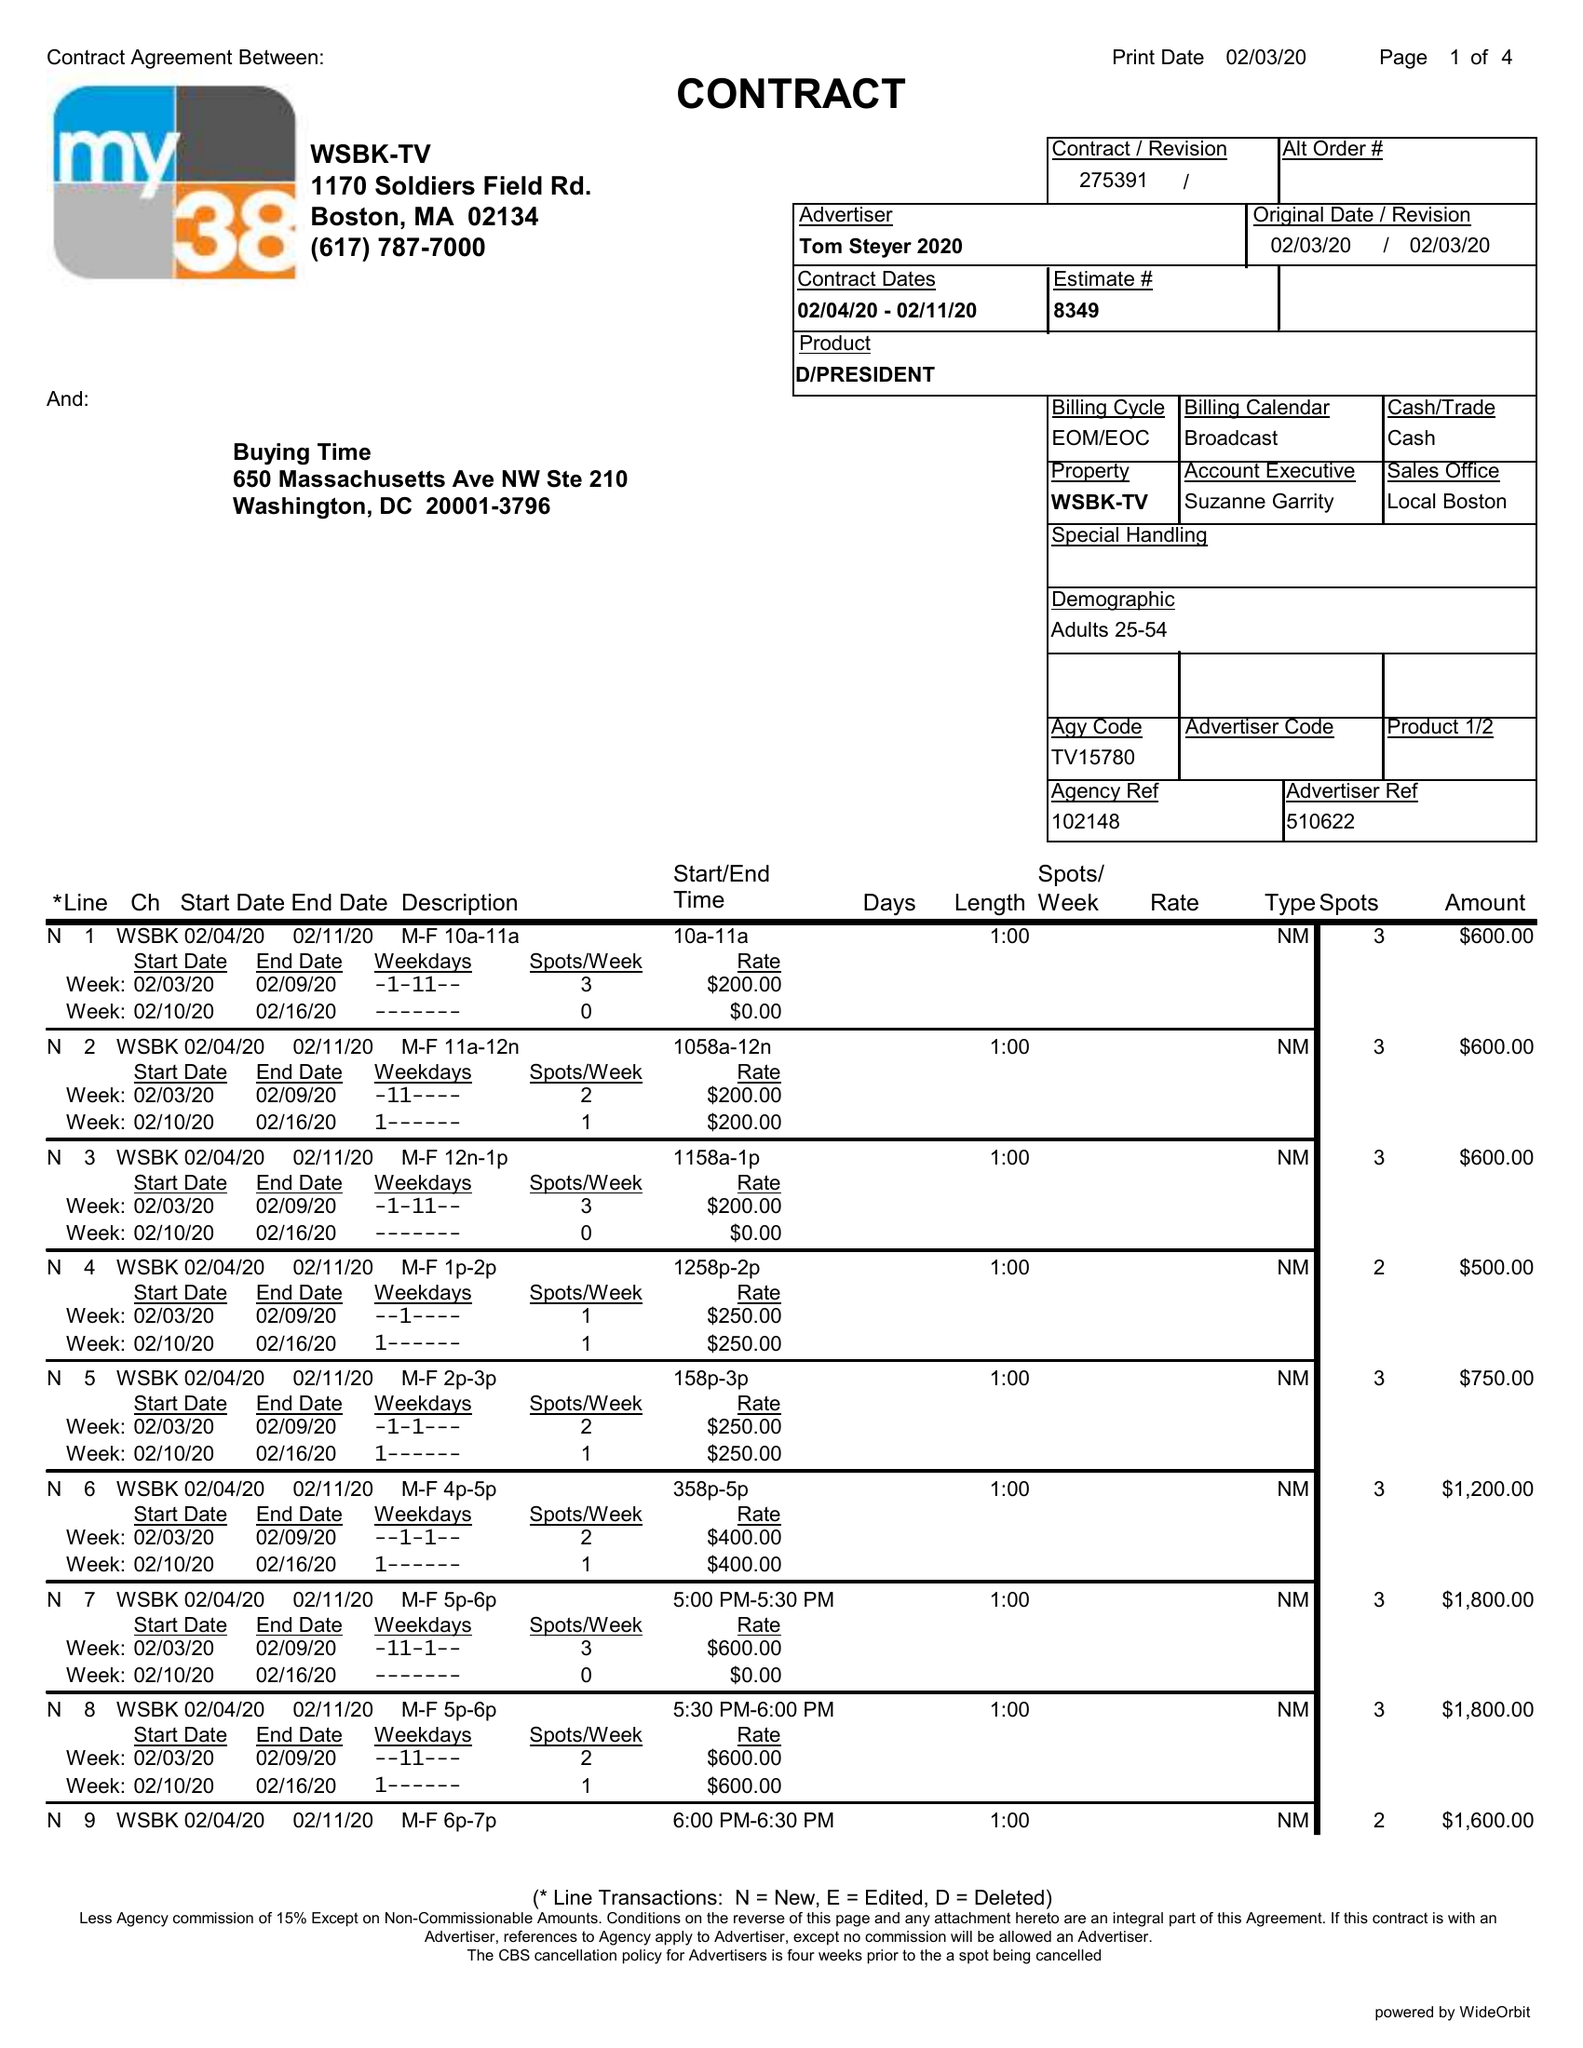What is the value for the flight_to?
Answer the question using a single word or phrase. 02/11/20 